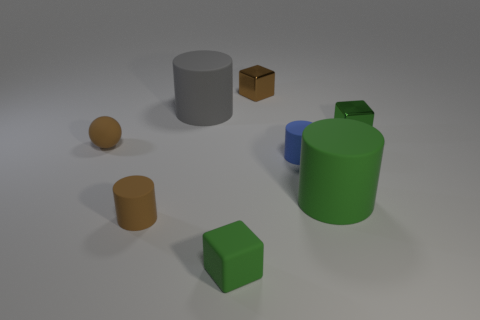What is the material of the cylinder that is the same color as the ball?
Offer a very short reply. Rubber. The cube that is made of the same material as the small brown ball is what color?
Keep it short and to the point. Green. Are there any other things that have the same size as the green metallic object?
Give a very brief answer. Yes. Does the rubber cylinder behind the sphere have the same color as the tiny metal cube left of the green rubber cylinder?
Your answer should be very brief. No. Is the number of matte cylinders that are in front of the blue matte cylinder greater than the number of green objects on the right side of the tiny brown metallic block?
Provide a short and direct response. No. What is the color of the other big thing that is the same shape as the gray object?
Make the answer very short. Green. Is there any other thing that has the same shape as the large green rubber thing?
Your answer should be very brief. Yes. There is a tiny green metal thing; is its shape the same as the brown thing that is behind the green metallic block?
Offer a very short reply. Yes. How many other things are there of the same material as the brown block?
Your answer should be very brief. 1. Does the small sphere have the same color as the tiny rubber cylinder that is on the left side of the tiny brown metallic thing?
Your response must be concise. Yes. 